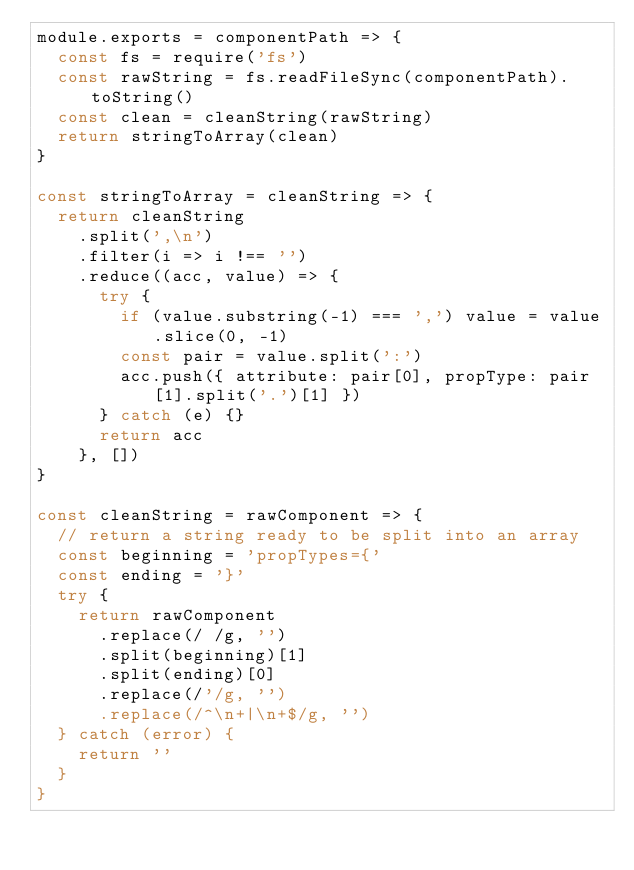Convert code to text. <code><loc_0><loc_0><loc_500><loc_500><_JavaScript_>module.exports = componentPath => {
  const fs = require('fs')
  const rawString = fs.readFileSync(componentPath).toString()
  const clean = cleanString(rawString)
  return stringToArray(clean)
}

const stringToArray = cleanString => {
  return cleanString
    .split(',\n')
    .filter(i => i !== '')
    .reduce((acc, value) => {
      try {
        if (value.substring(-1) === ',') value = value.slice(0, -1)
        const pair = value.split(':')
        acc.push({ attribute: pair[0], propType: pair[1].split('.')[1] })
      } catch (e) {}
      return acc
    }, [])
}

const cleanString = rawComponent => {
  // return a string ready to be split into an array
  const beginning = 'propTypes={'
  const ending = '}'
  try {
    return rawComponent
      .replace(/ /g, '')
      .split(beginning)[1]
      .split(ending)[0]
      .replace(/'/g, '')
      .replace(/^\n+|\n+$/g, '')
  } catch (error) {
    return ''
  }
}
</code> 